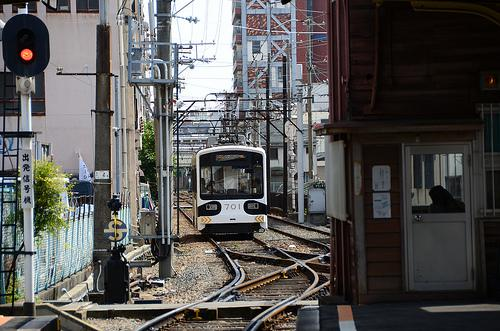Question: who is present?
Choices:
A. Policeman.
B. Nobody.
C. Firefighter.
D. Judge.
Answer with the letter. Answer: B Question: where was this photo taken?
Choices:
A. Airport.
B. Harbor.
C. Train station.
D. Bus stop.
Answer with the letter. Answer: C Question: how is the photo?
Choices:
A. Blurry.
B. Foggy.
C. Muggy.
D. Clear.
Answer with the letter. Answer: D Question: what is it on?
Choices:
A. Street.
B. Sidewalk.
C. Grass.
D. Rail tracks.
Answer with the letter. Answer: D 